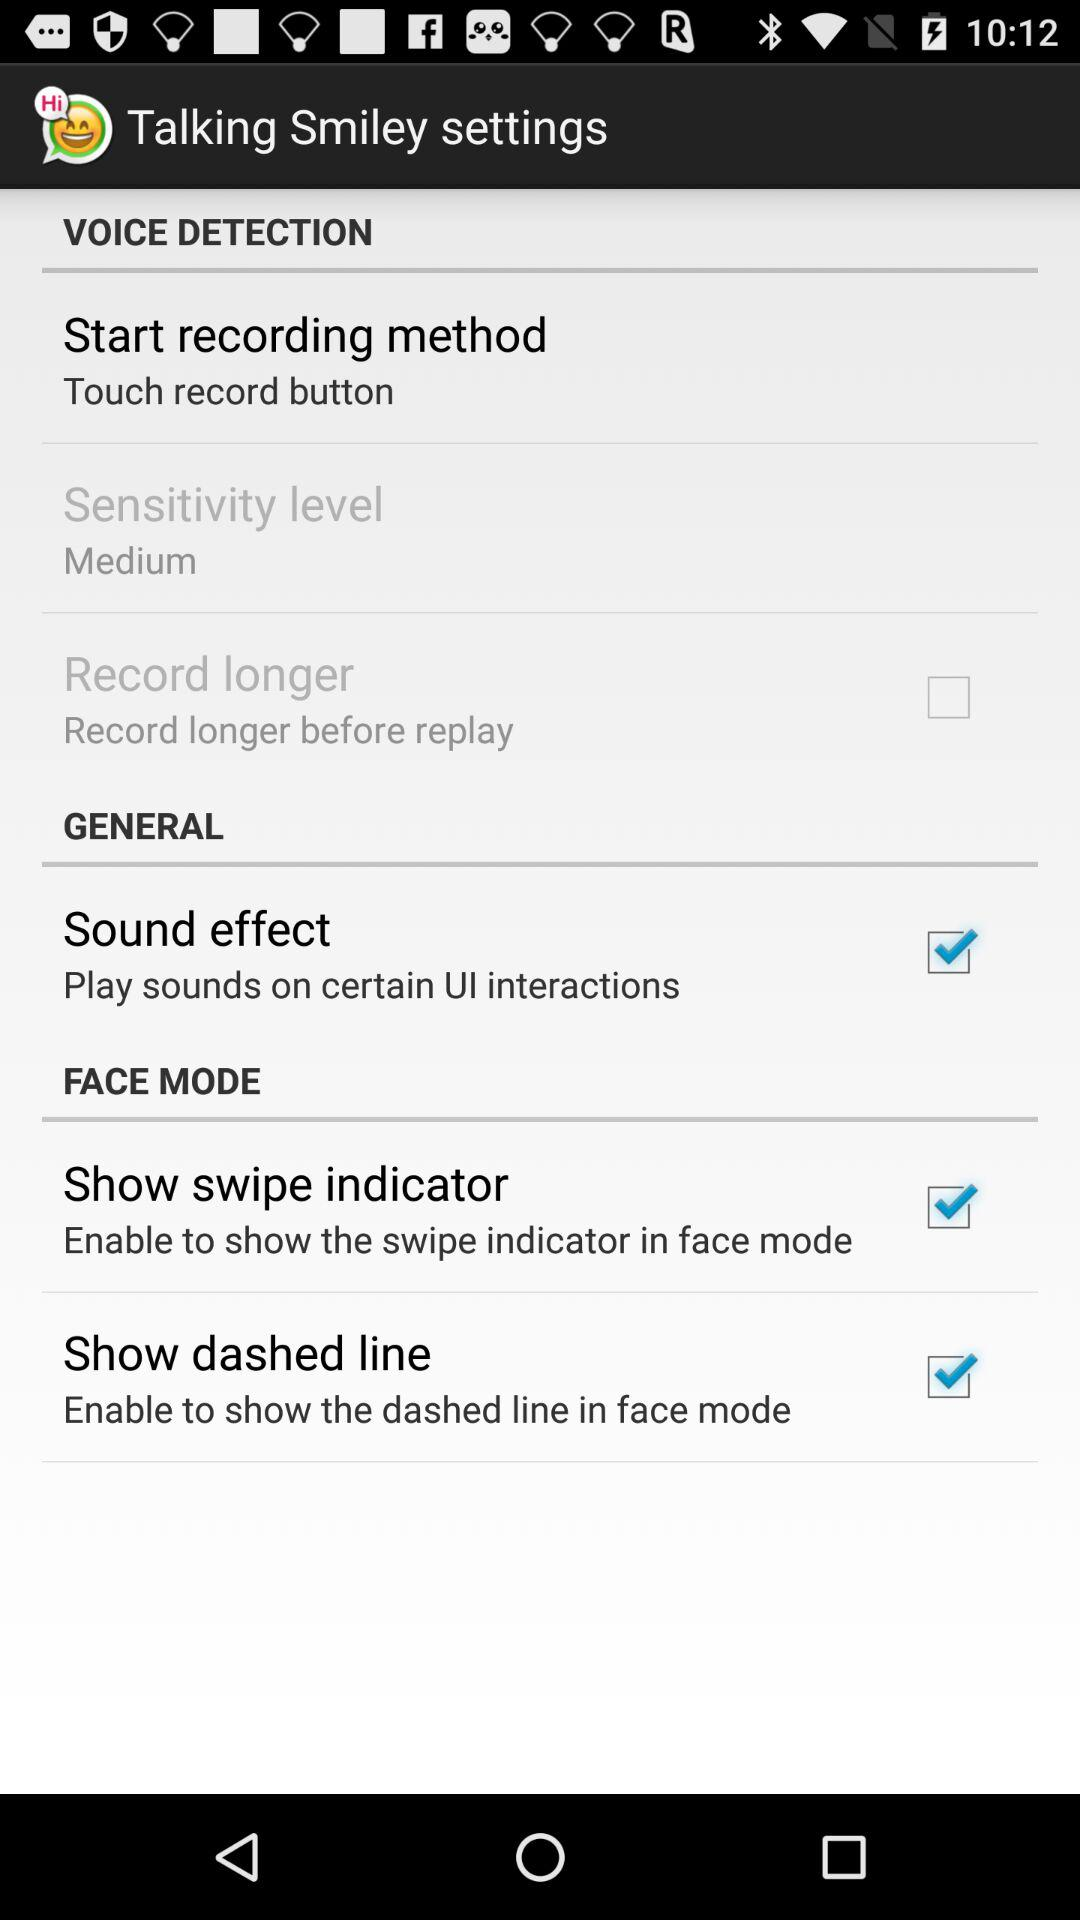What is the status of "Show dashed line"? The status is "on". 